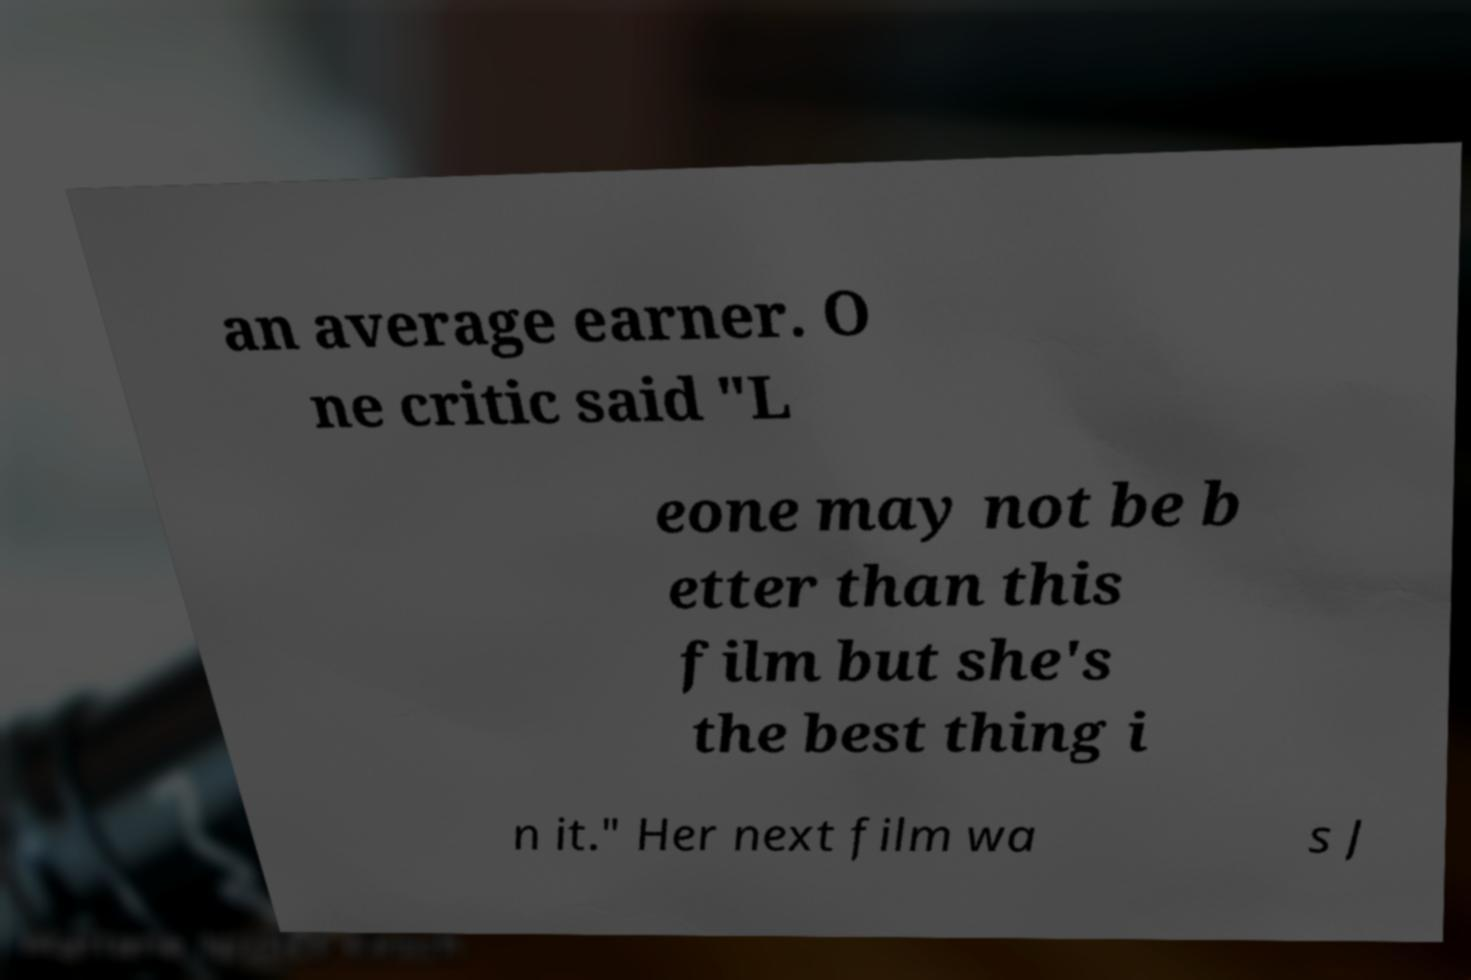I need the written content from this picture converted into text. Can you do that? an average earner. O ne critic said "L eone may not be b etter than this film but she's the best thing i n it." Her next film wa s J 